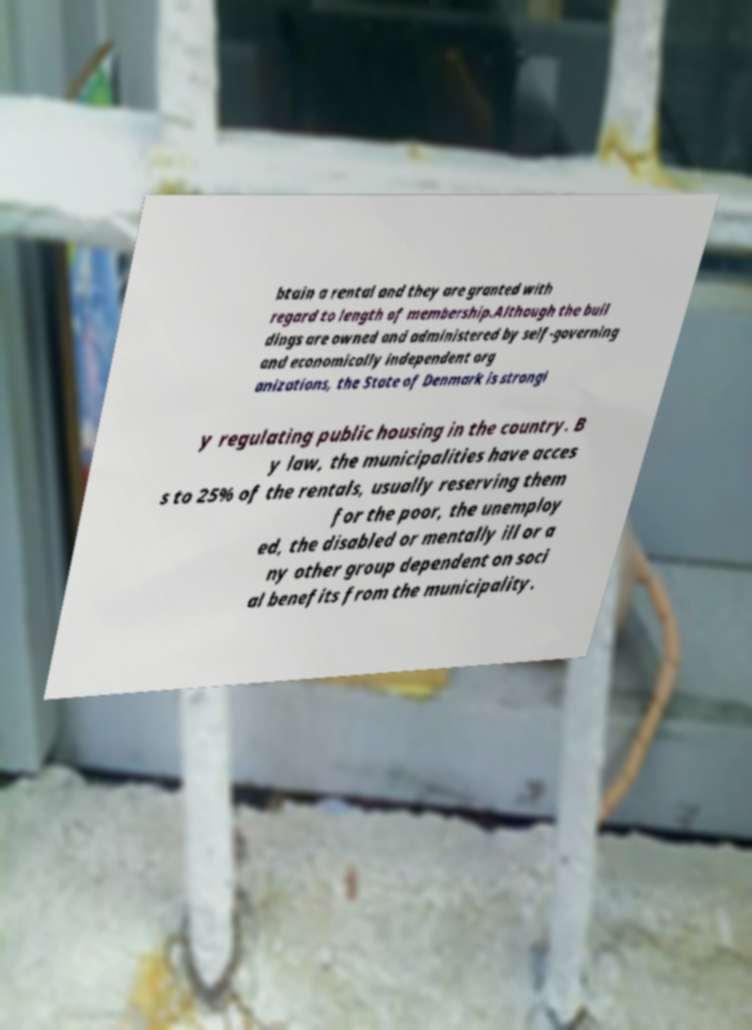Please read and relay the text visible in this image. What does it say? btain a rental and they are granted with regard to length of membership.Although the buil dings are owned and administered by self-governing and economically independent org anizations, the State of Denmark is strongl y regulating public housing in the country. B y law, the municipalities have acces s to 25% of the rentals, usually reserving them for the poor, the unemploy ed, the disabled or mentally ill or a ny other group dependent on soci al benefits from the municipality. 